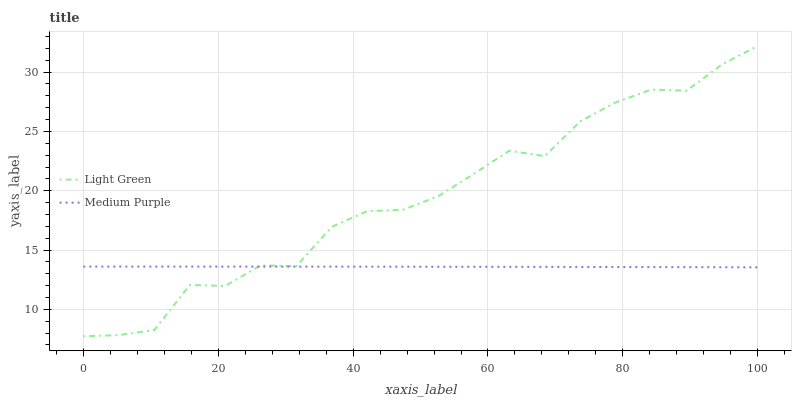Does Medium Purple have the minimum area under the curve?
Answer yes or no. Yes. Does Light Green have the maximum area under the curve?
Answer yes or no. Yes. Does Light Green have the minimum area under the curve?
Answer yes or no. No. Is Medium Purple the smoothest?
Answer yes or no. Yes. Is Light Green the roughest?
Answer yes or no. Yes. Is Light Green the smoothest?
Answer yes or no. No. Does Light Green have the lowest value?
Answer yes or no. Yes. Does Light Green have the highest value?
Answer yes or no. Yes. Does Medium Purple intersect Light Green?
Answer yes or no. Yes. Is Medium Purple less than Light Green?
Answer yes or no. No. Is Medium Purple greater than Light Green?
Answer yes or no. No. 